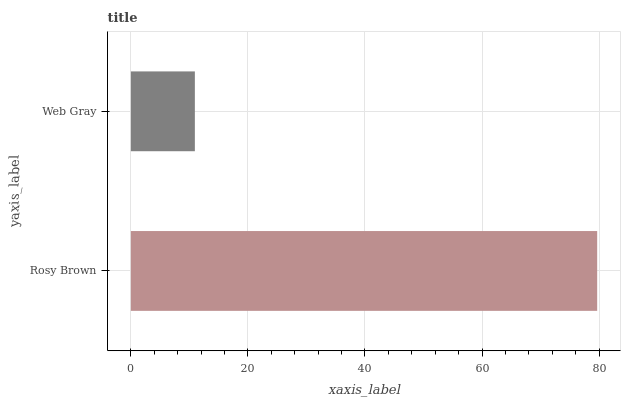Is Web Gray the minimum?
Answer yes or no. Yes. Is Rosy Brown the maximum?
Answer yes or no. Yes. Is Web Gray the maximum?
Answer yes or no. No. Is Rosy Brown greater than Web Gray?
Answer yes or no. Yes. Is Web Gray less than Rosy Brown?
Answer yes or no. Yes. Is Web Gray greater than Rosy Brown?
Answer yes or no. No. Is Rosy Brown less than Web Gray?
Answer yes or no. No. Is Rosy Brown the high median?
Answer yes or no. Yes. Is Web Gray the low median?
Answer yes or no. Yes. Is Web Gray the high median?
Answer yes or no. No. Is Rosy Brown the low median?
Answer yes or no. No. 